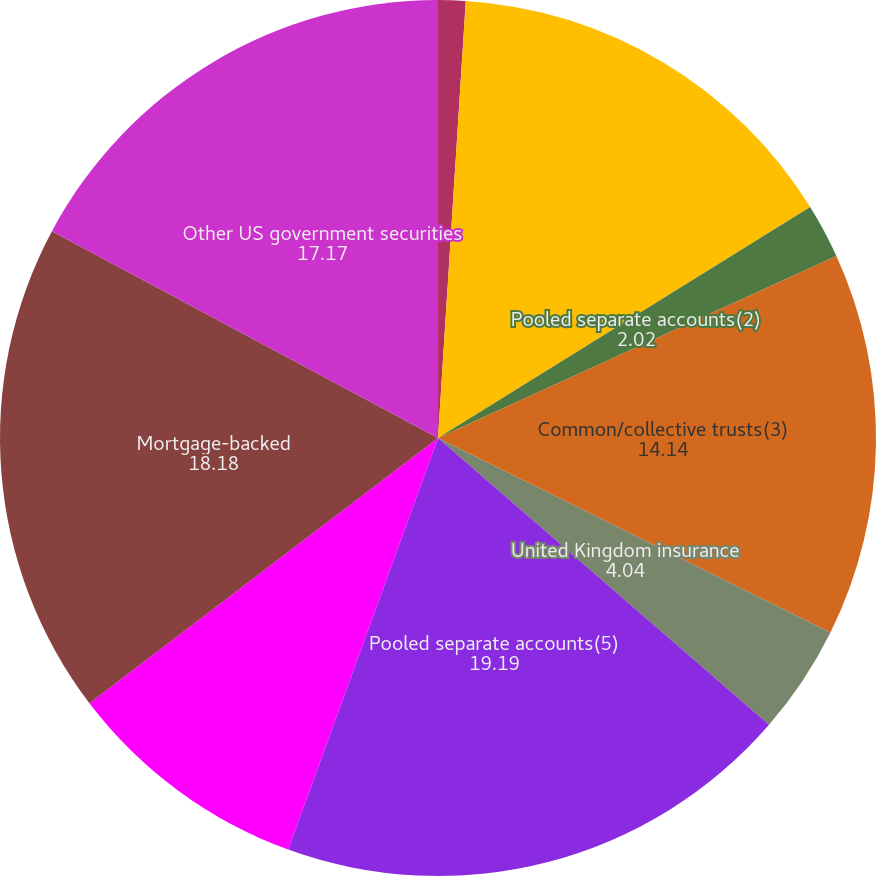Convert chart to OTSL. <chart><loc_0><loc_0><loc_500><loc_500><pie_chart><fcel>Pooled separate accounts(1)<fcel>Common/collective trusts(1)<fcel>Pooled separate accounts(2)<fcel>Common/collective trusts(3)<fcel>United Kingdom insurance<fcel>Pooled separate accounts(5)<fcel>Common/collective trusts(6)<fcel>Mortgage-backed<fcel>Other US government securities<fcel>US government securities<nl><fcel>1.01%<fcel>15.15%<fcel>2.02%<fcel>14.14%<fcel>4.04%<fcel>19.19%<fcel>9.09%<fcel>18.18%<fcel>17.17%<fcel>0.0%<nl></chart> 